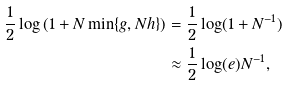Convert formula to latex. <formula><loc_0><loc_0><loc_500><loc_500>\frac { 1 } { 2 } \log \left ( 1 + N \min \{ g , N h \} \right ) & = \frac { 1 } { 2 } \log ( 1 + N ^ { - 1 } ) \\ & \approx \frac { 1 } { 2 } \log ( e ) N ^ { - 1 } ,</formula> 